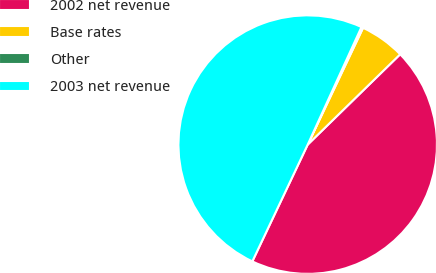<chart> <loc_0><loc_0><loc_500><loc_500><pie_chart><fcel>2002 net revenue<fcel>Base rates<fcel>Other<fcel>2003 net revenue<nl><fcel>44.36%<fcel>5.64%<fcel>0.22%<fcel>49.78%<nl></chart> 